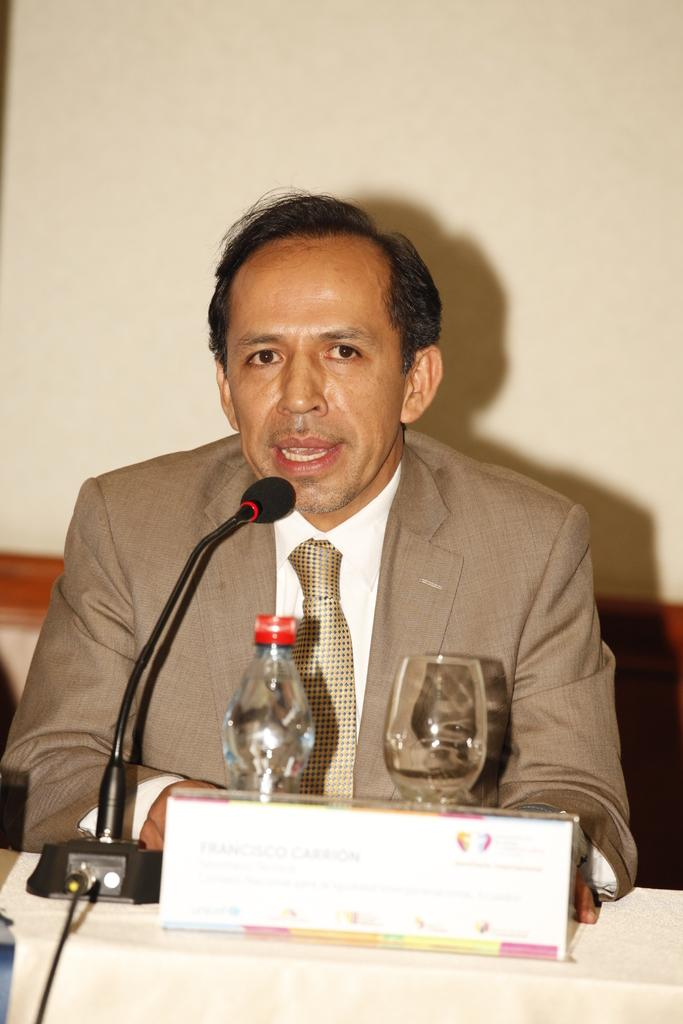What is the man in the image doing? The man is sitting near the table in the image. What objects are on the table in the image? There is a glass, a bottle, and a microphone on the table in the image. How many cherries are on the man's neck in the image? There are no cherries present on the man's neck in the image. 